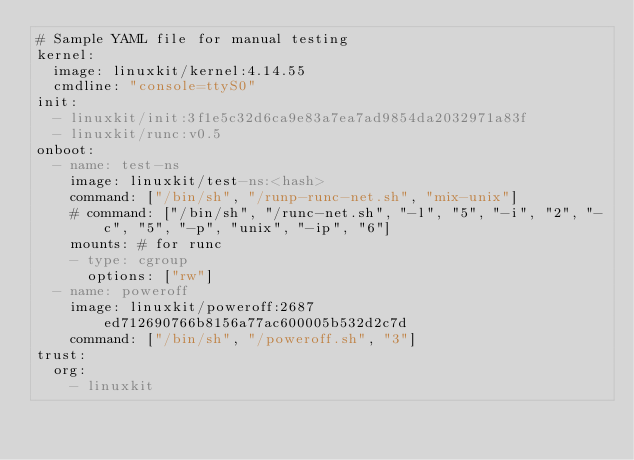Convert code to text. <code><loc_0><loc_0><loc_500><loc_500><_YAML_># Sample YAML file for manual testing
kernel:
  image: linuxkit/kernel:4.14.55
  cmdline: "console=ttyS0"
init:
  - linuxkit/init:3f1e5c32d6ca9e83a7ea7ad9854da2032971a83f
  - linuxkit/runc:v0.5
onboot:
  - name: test-ns
    image: linuxkit/test-ns:<hash>
    command: ["/bin/sh", "/runp-runc-net.sh", "mix-unix"]
    # command: ["/bin/sh", "/runc-net.sh", "-l", "5", "-i", "2", "-c", "5", "-p", "unix", "-ip", "6"]
    mounts: # for runc
    - type: cgroup
      options: ["rw"]
  - name: poweroff
    image: linuxkit/poweroff:2687ed712690766b8156a77ac600005b532d2c7d
    command: ["/bin/sh", "/poweroff.sh", "3"]
trust:
  org:
    - linuxkit
</code> 